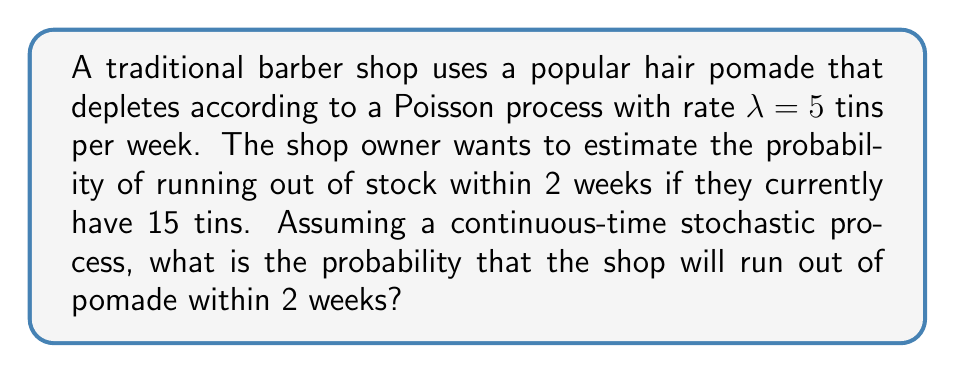Solve this math problem. To solve this problem, we'll use the properties of the Poisson process:

1) The number of events (tins used) in a time interval $t$ follows a Poisson distribution with mean $\lambda t$.

2) For this case, $\lambda = 5$ tins/week and $t = 2$ weeks, so the mean is $\lambda t = 5 \cdot 2 = 10$ tins.

3) We want to find the probability of using more than 15 tins in 2 weeks. This is equivalent to finding the probability of 16 or more events occurring.

4) Let $X$ be the number of tins used in 2 weeks. We need to calculate:

   $P(X \geq 16) = 1 - P(X \leq 15)$

5) The cumulative distribution function of the Poisson distribution is:

   $P(X \leq k) = e^{-\lambda t} \sum_{i=0}^k \frac{(\lambda t)^i}{i!}$

6) Substituting our values:

   $P(X \leq 15) = e^{-10} \sum_{i=0}^{15} \frac{10^i}{i!}$

7) This can be calculated using statistical software or a calculator with a Poisson CDF function. The result is approximately 0.9513.

8) Therefore, the probability of running out of stock (using 16 or more tins) is:

   $P(X \geq 16) = 1 - P(X \leq 15) = 1 - 0.9513 \approx 0.0487$
Answer: 0.0487 